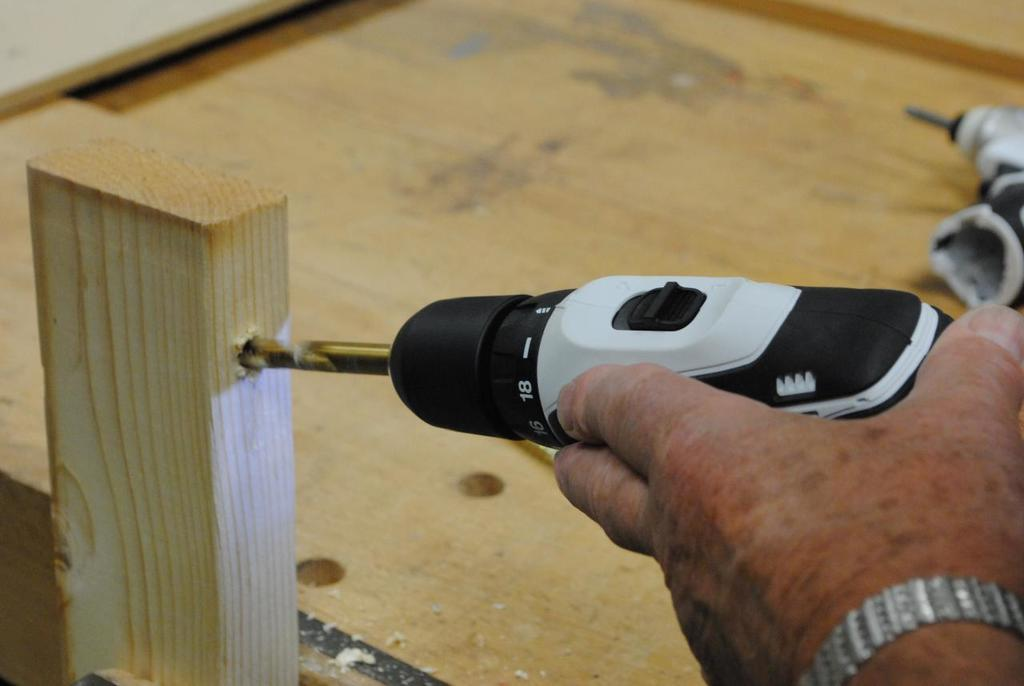What is the person in the image doing? The person is making holes in a wooden stick. What tool is the person using to make the holes? The person is using a drill to make the holes. What can be seen on the wooden surface in the image? There is an object placed on a wooden surface in the image. What type of leaf can be seen falling in the image? There is no leaf or indication of rain in the image; it shows a person using a drill to make holes in a wooden stick. 